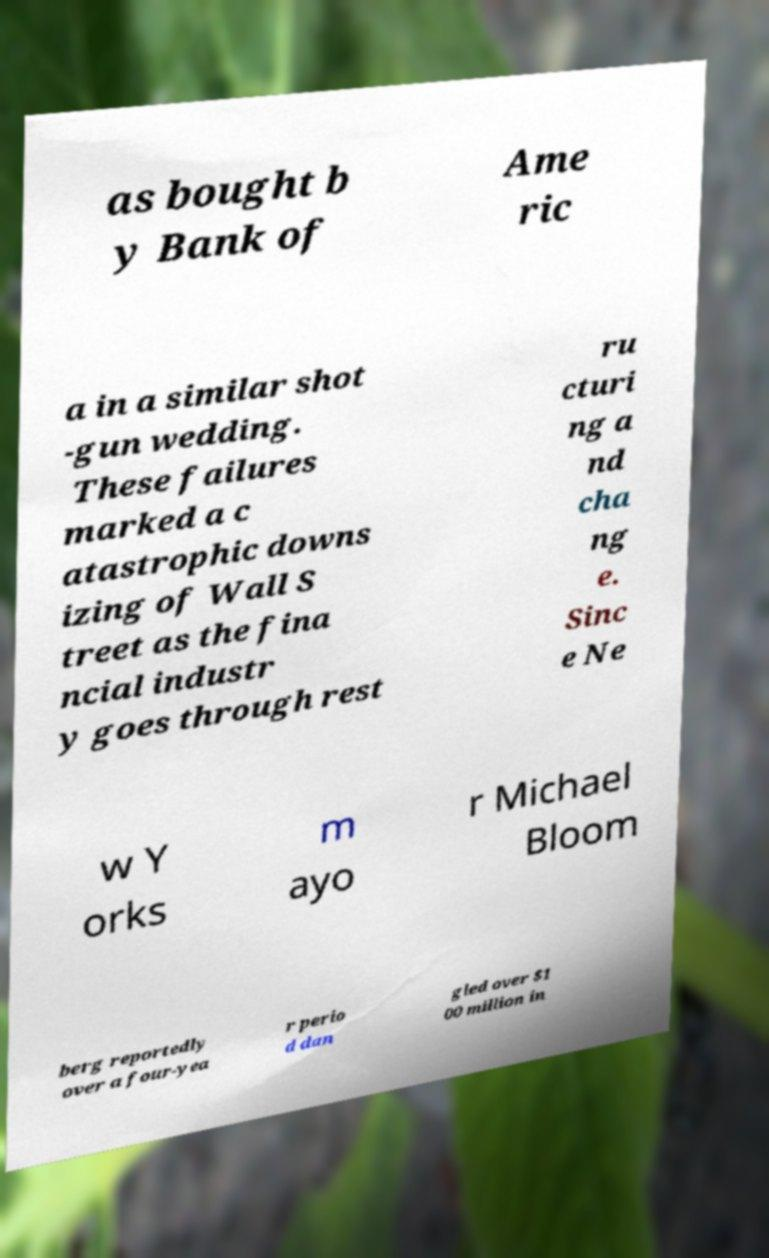Could you assist in decoding the text presented in this image and type it out clearly? as bought b y Bank of Ame ric a in a similar shot -gun wedding. These failures marked a c atastrophic downs izing of Wall S treet as the fina ncial industr y goes through rest ru cturi ng a nd cha ng e. Sinc e Ne w Y orks m ayo r Michael Bloom berg reportedly over a four-yea r perio d dan gled over $1 00 million in 